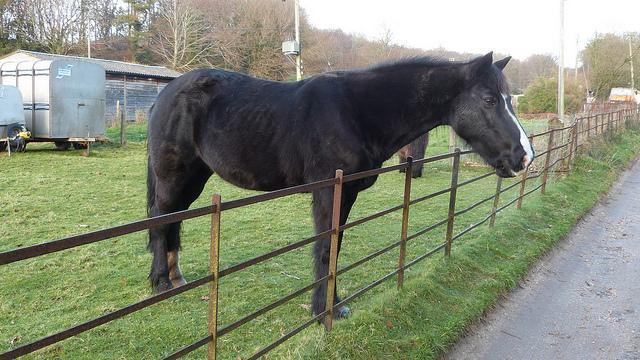How many people are wearing white shirt?
Give a very brief answer. 0. 